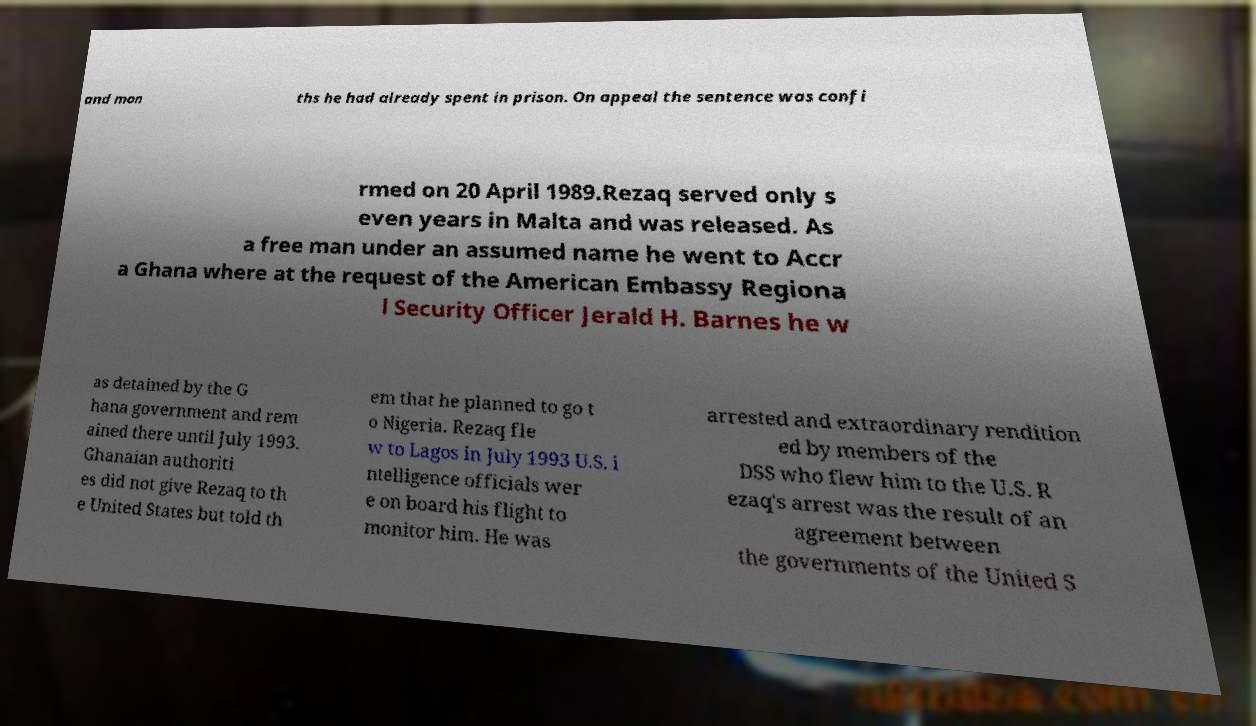Could you assist in decoding the text presented in this image and type it out clearly? and mon ths he had already spent in prison. On appeal the sentence was confi rmed on 20 April 1989.Rezaq served only s even years in Malta and was released. As a free man under an assumed name he went to Accr a Ghana where at the request of the American Embassy Regiona l Security Officer Jerald H. Barnes he w as detained by the G hana government and rem ained there until July 1993. Ghanaian authoriti es did not give Rezaq to th e United States but told th em that he planned to go t o Nigeria. Rezaq fle w to Lagos in July 1993 U.S. i ntelligence officials wer e on board his flight to monitor him. He was arrested and extraordinary rendition ed by members of the DSS who flew him to the U.S. R ezaq's arrest was the result of an agreement between the governments of the United S 